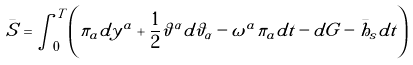<formula> <loc_0><loc_0><loc_500><loc_500>\bar { S } = \int _ { 0 } ^ { T } \left ( \pi _ { a } d y ^ { a } + { \frac { 1 } { 2 } } \vartheta ^ { \alpha } d \vartheta _ { \alpha } - \omega ^ { a } \pi _ { a } d t - d G - \bar { h } _ { s } d t \right )</formula> 